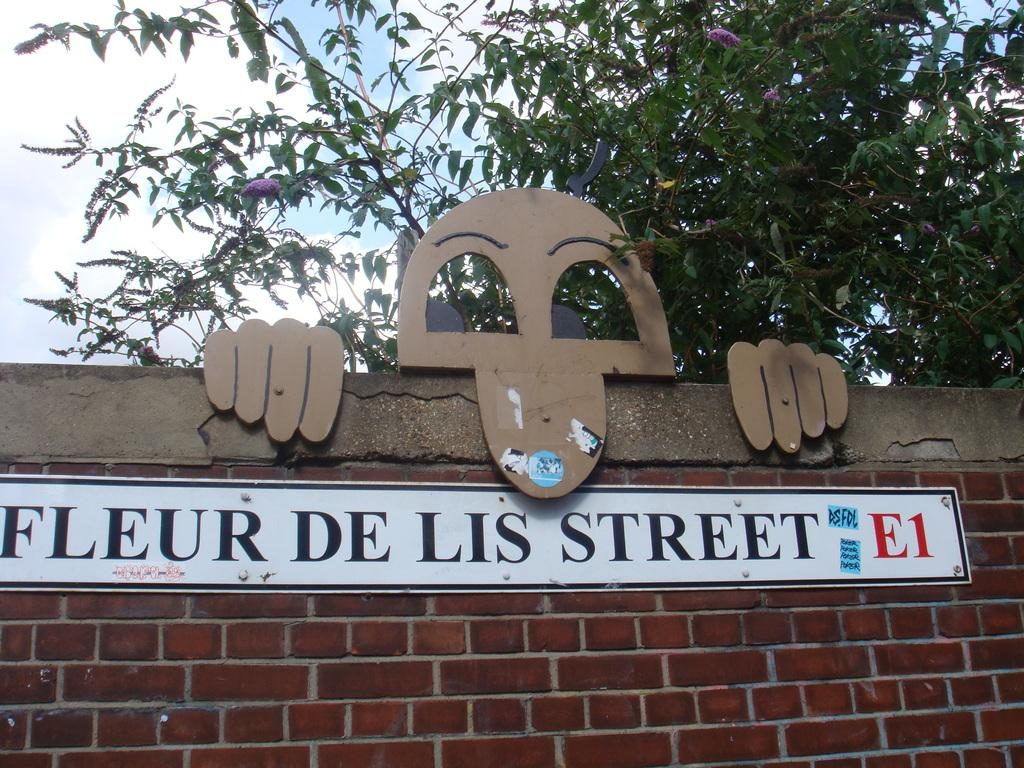What is present on the wall in the image? There is a board on the wall. Are there any other boards visible on the wall? Yes, there is another board in brown color at the top. What else can be seen in the image besides the wall and boards? There is a tree in the image. What part of the natural environment is visible in the image? The sky is visible in the image. How many times has the tree in the image been requested to work? There is no indication in the image that the tree is capable of working or has been requested to do so. 